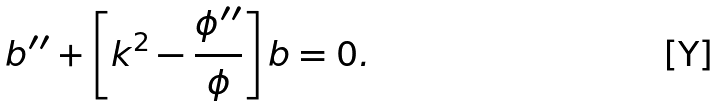<formula> <loc_0><loc_0><loc_500><loc_500>b ^ { \prime \prime } + \left [ k ^ { 2 } - \frac { \phi ^ { \prime \prime } } { \phi } \right ] b = 0 .</formula> 